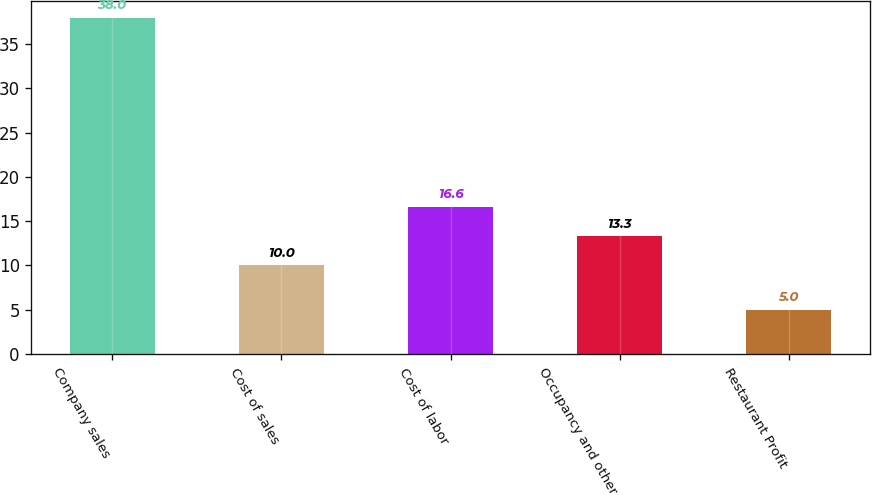Convert chart. <chart><loc_0><loc_0><loc_500><loc_500><bar_chart><fcel>Company sales<fcel>Cost of sales<fcel>Cost of labor<fcel>Occupancy and other<fcel>Restaurant Profit<nl><fcel>38<fcel>10<fcel>16.6<fcel>13.3<fcel>5<nl></chart> 